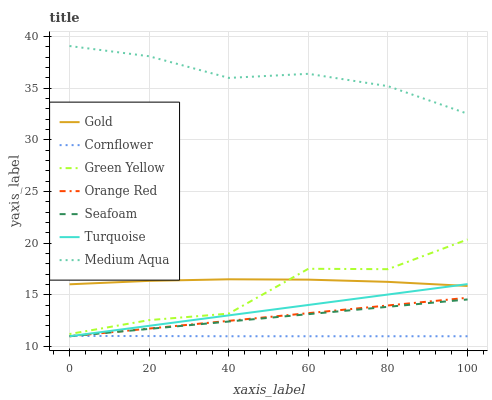Does Turquoise have the minimum area under the curve?
Answer yes or no. No. Does Turquoise have the maximum area under the curve?
Answer yes or no. No. Is Turquoise the smoothest?
Answer yes or no. No. Is Turquoise the roughest?
Answer yes or no. No. Does Gold have the lowest value?
Answer yes or no. No. Does Turquoise have the highest value?
Answer yes or no. No. Is Seafoam less than Green Yellow?
Answer yes or no. Yes. Is Green Yellow greater than Cornflower?
Answer yes or no. Yes. Does Seafoam intersect Green Yellow?
Answer yes or no. No. 